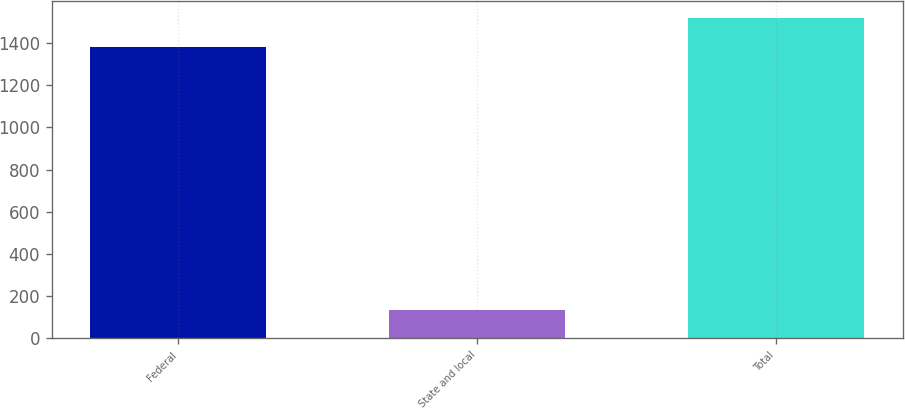Convert chart. <chart><loc_0><loc_0><loc_500><loc_500><bar_chart><fcel>Federal<fcel>State and local<fcel>Total<nl><fcel>1382<fcel>135<fcel>1522<nl></chart> 